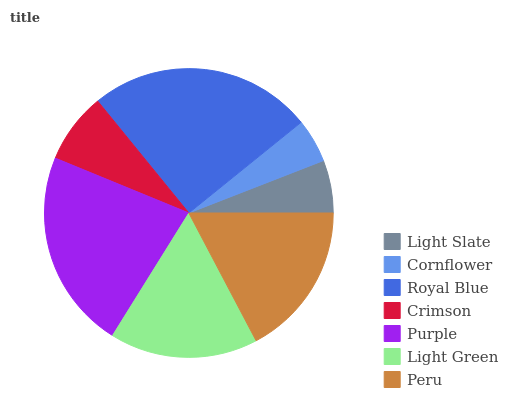Is Cornflower the minimum?
Answer yes or no. Yes. Is Royal Blue the maximum?
Answer yes or no. Yes. Is Royal Blue the minimum?
Answer yes or no. No. Is Cornflower the maximum?
Answer yes or no. No. Is Royal Blue greater than Cornflower?
Answer yes or no. Yes. Is Cornflower less than Royal Blue?
Answer yes or no. Yes. Is Cornflower greater than Royal Blue?
Answer yes or no. No. Is Royal Blue less than Cornflower?
Answer yes or no. No. Is Light Green the high median?
Answer yes or no. Yes. Is Light Green the low median?
Answer yes or no. Yes. Is Peru the high median?
Answer yes or no. No. Is Crimson the low median?
Answer yes or no. No. 